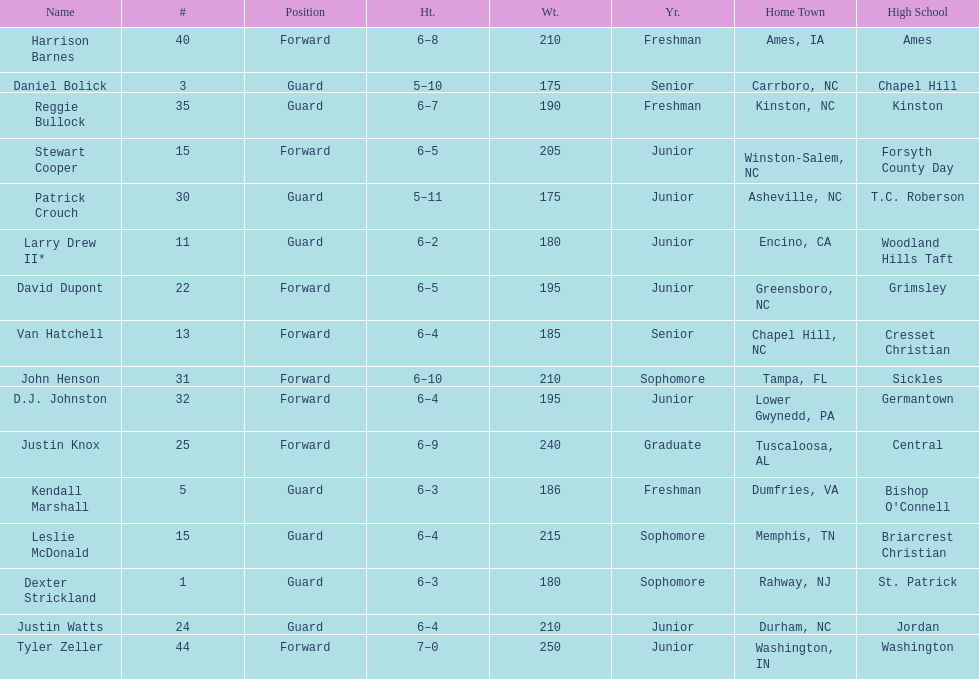Names of players who were exactly 6 feet, 4 inches tall, but did not weight over 200 pounds Van Hatchell, D.J. Johnston. 